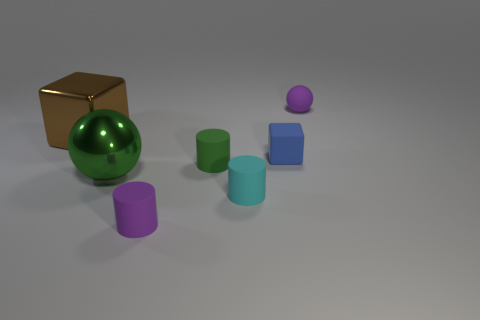There is a sphere that is behind the green metal thing that is behind the cyan matte object; what is it made of?
Provide a succinct answer. Rubber. What is the shape of the tiny thing that is both on the left side of the cyan object and in front of the shiny sphere?
Give a very brief answer. Cylinder. What number of other things are there of the same color as the matte cube?
Offer a terse response. 0. How many objects are balls on the right side of the shiny sphere or matte cylinders?
Provide a short and direct response. 4. There is a tiny ball; is its color the same as the big metal thing behind the blue object?
Keep it short and to the point. No. Is there anything else that has the same size as the purple rubber ball?
Give a very brief answer. Yes. How big is the purple thing behind the large object in front of the blue block?
Give a very brief answer. Small. What number of things are either green balls or large objects that are in front of the rubber block?
Your response must be concise. 1. There is a purple matte object that is on the left side of the purple matte ball; is its shape the same as the small cyan rubber object?
Your answer should be compact. Yes. There is a metal thing behind the sphere that is in front of the blue cube; how many small cyan cylinders are to the left of it?
Offer a very short reply. 0. 